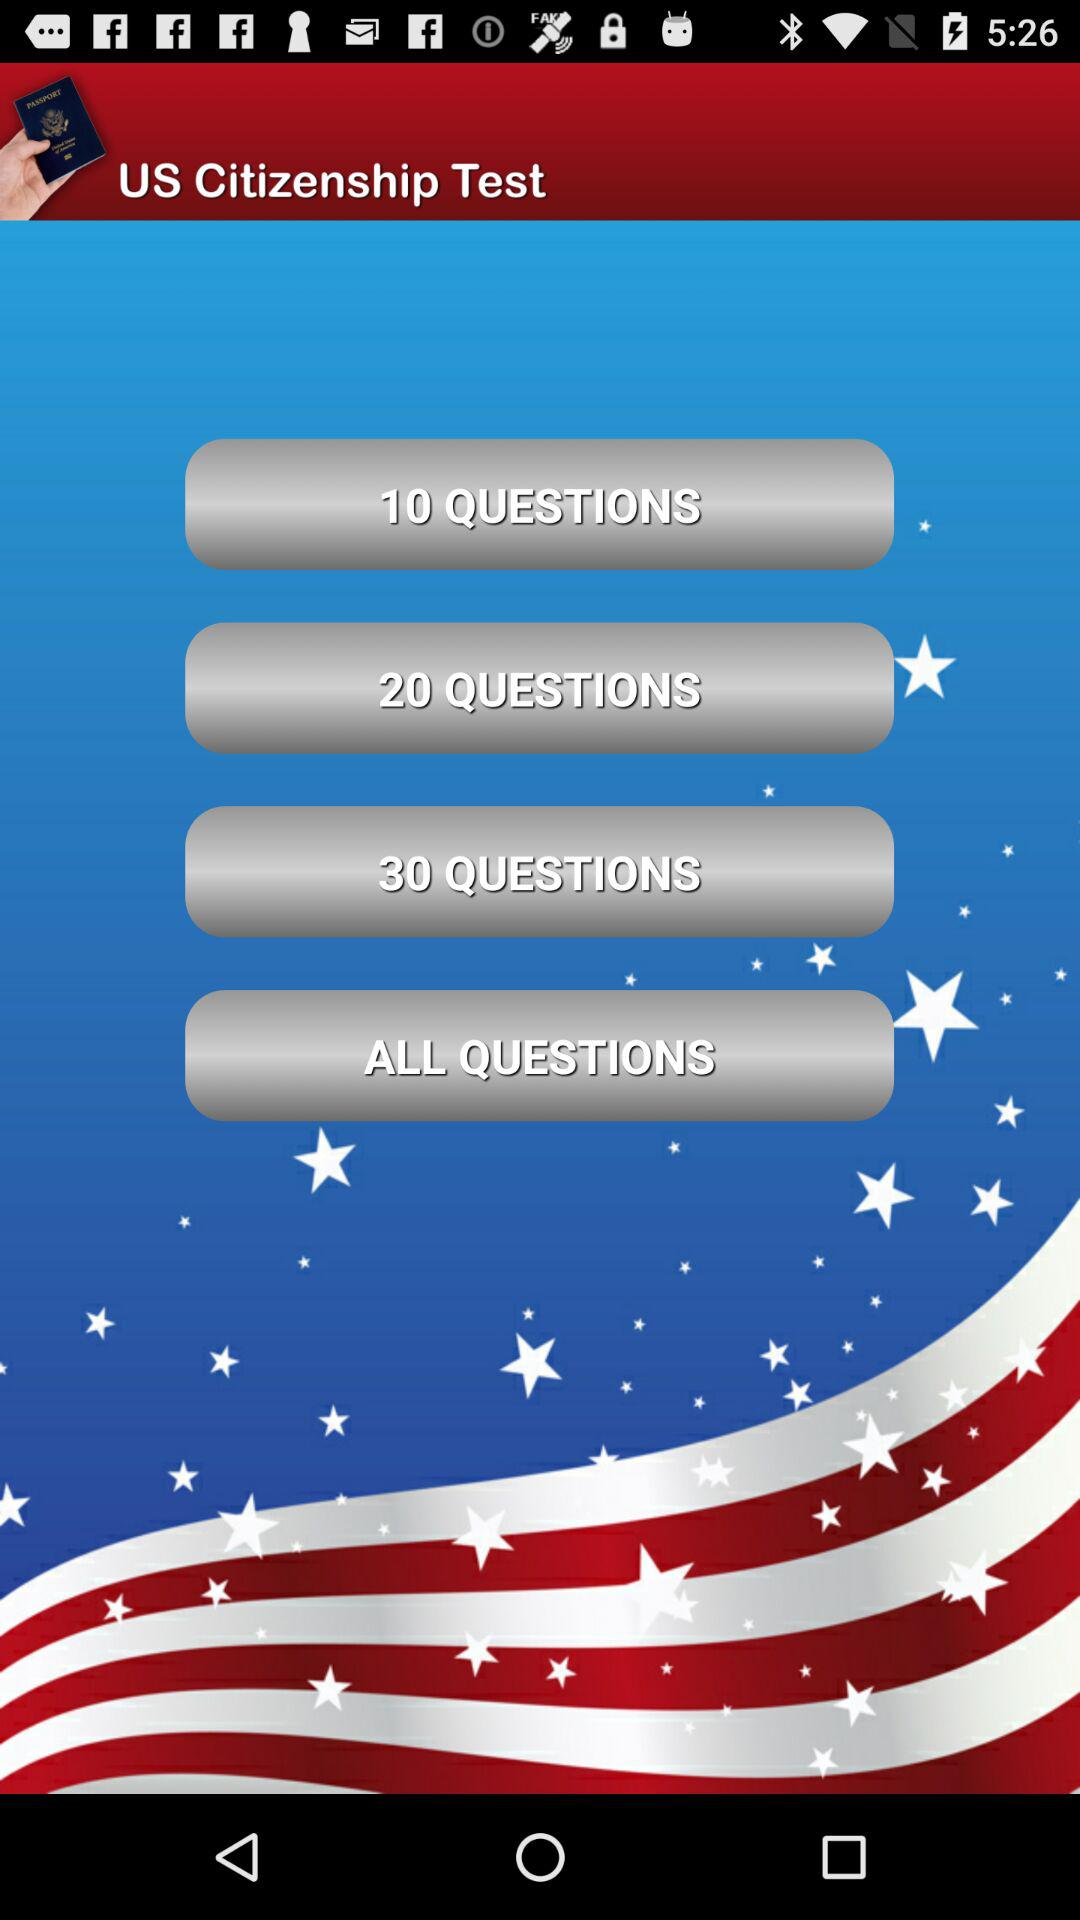What is the name of the test? The name of the test is "US Citizenship Test". 